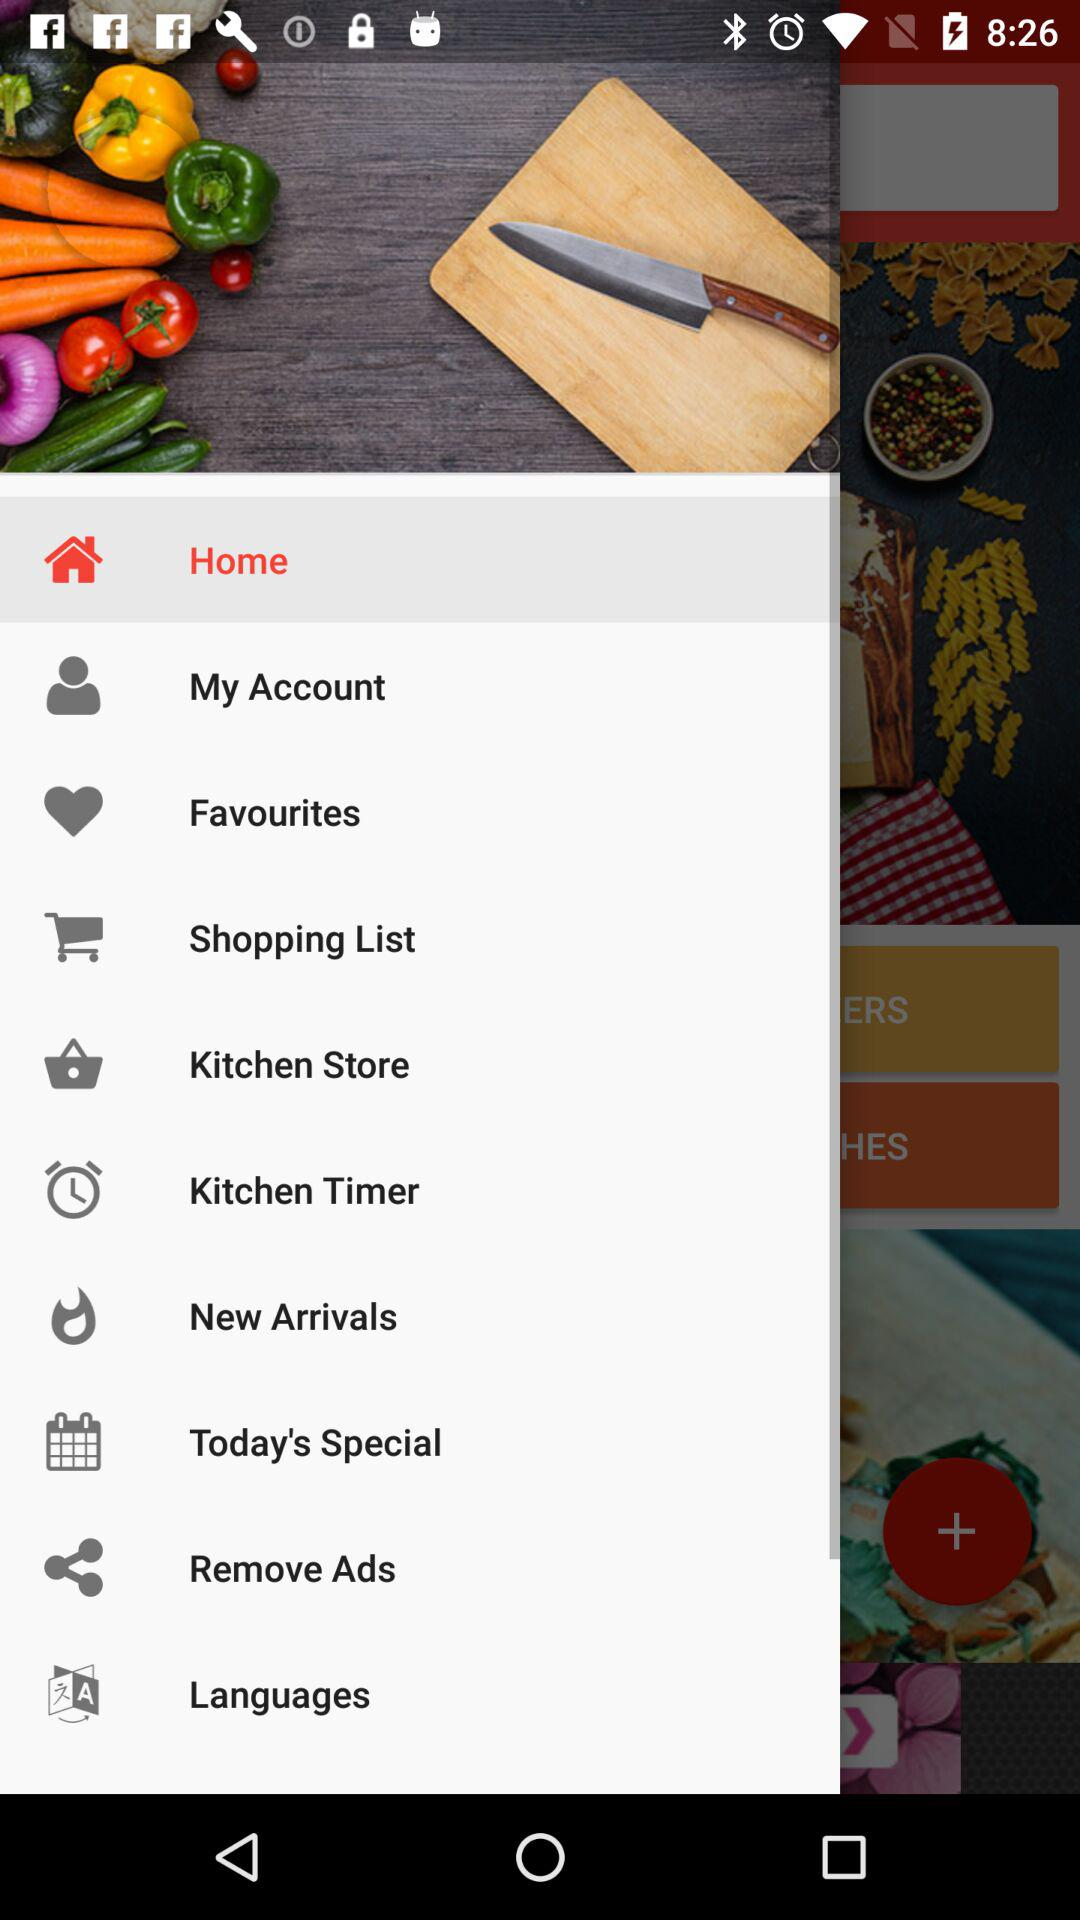What is the selected option? The selected option is "Home". 